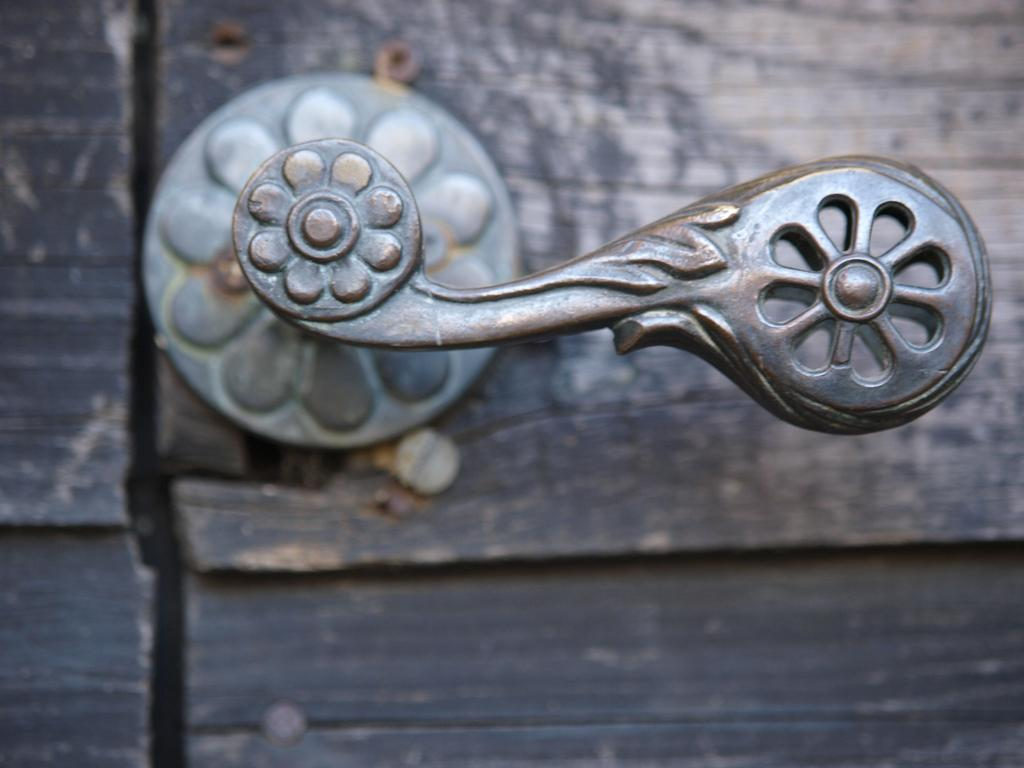What object can be seen in the image that is used for opening or closing a door? There is a door handle in the image. What type of skirt is being discussed by the committee in the image? There is no committee or skirt present in the image; it only features a door handle. 